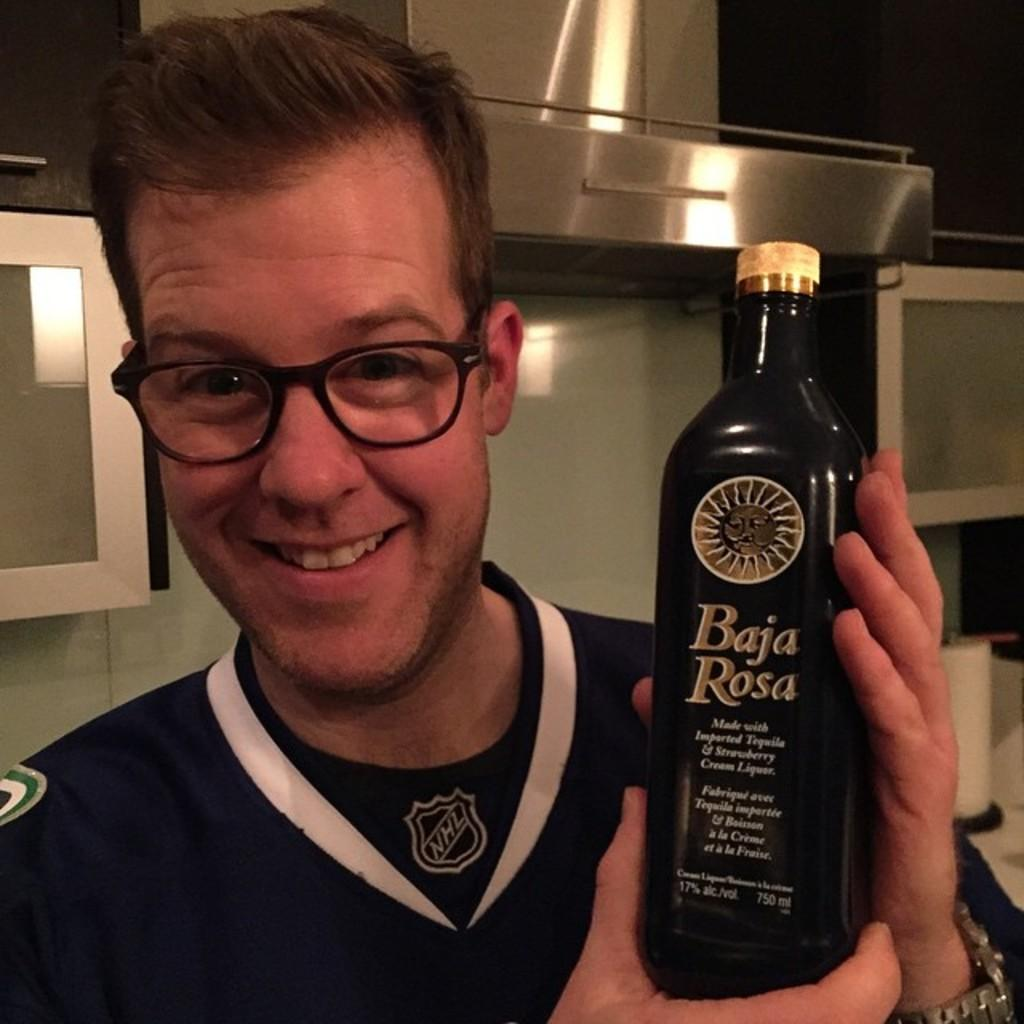<image>
Summarize the visual content of the image. A smiling man holds a bottle of Baja Rosa. 